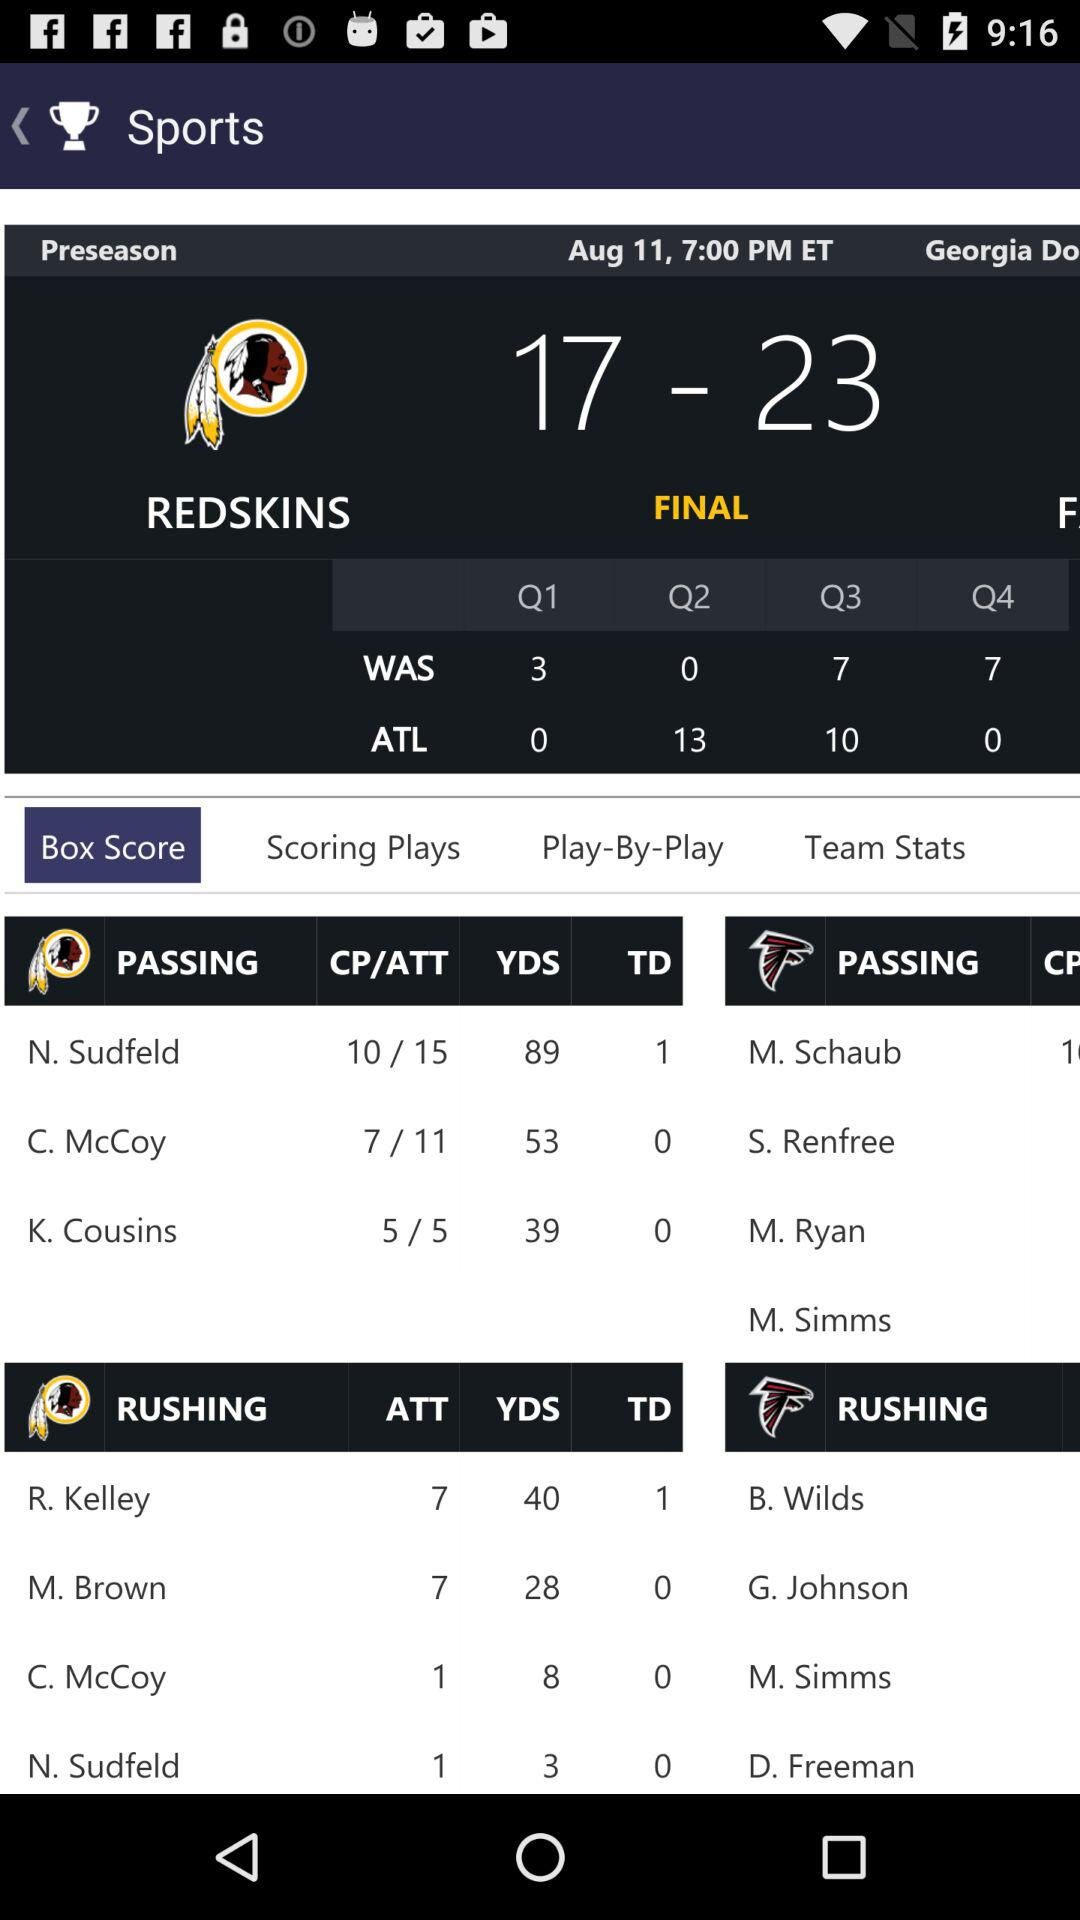Which tab is selected? The selected tab is "Box Score". 